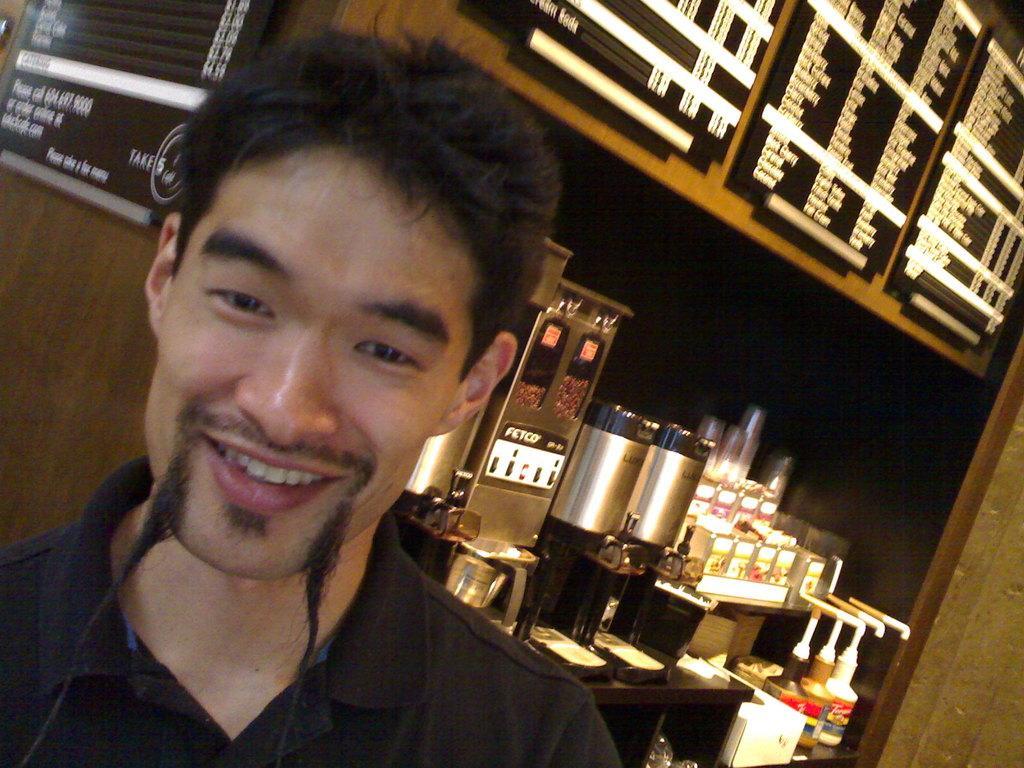In one or two sentences, can you explain what this image depicts? In this picture I can see a man smiling, and in the background there are boards attached to the wall, there are some machines, glasses, bottles and some other items in the racks. 